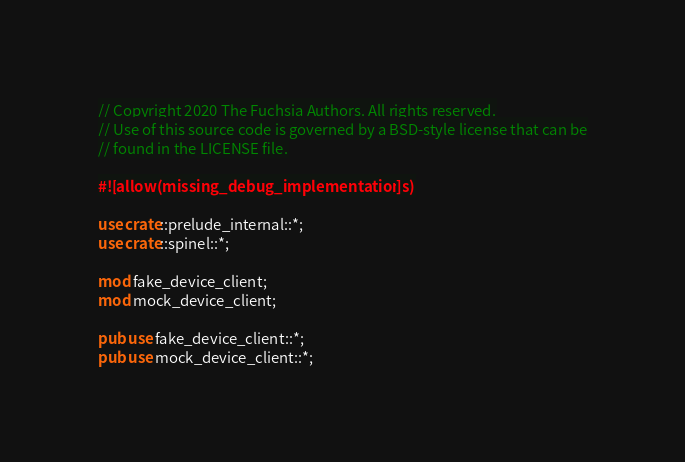<code> <loc_0><loc_0><loc_500><loc_500><_Rust_>// Copyright 2020 The Fuchsia Authors. All rights reserved.
// Use of this source code is governed by a BSD-style license that can be
// found in the LICENSE file.

#![allow(missing_debug_implementations)]

use crate::prelude_internal::*;
use crate::spinel::*;

mod fake_device_client;
mod mock_device_client;

pub use fake_device_client::*;
pub use mock_device_client::*;
</code> 